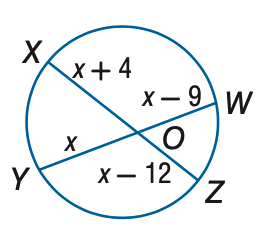Answer the mathemtical geometry problem and directly provide the correct option letter.
Question: Find x to the nearest tenth. Assume that segments that appear to be tangent are tangent.
Choices: A: 24 B: 36 C: 48 D: 60 C 